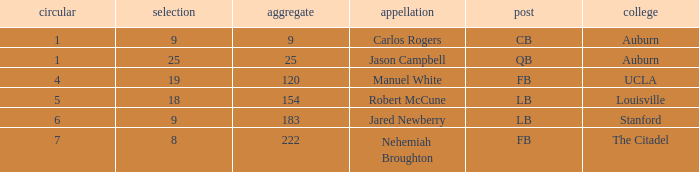Which college had an overall pick of 9? Auburn. 